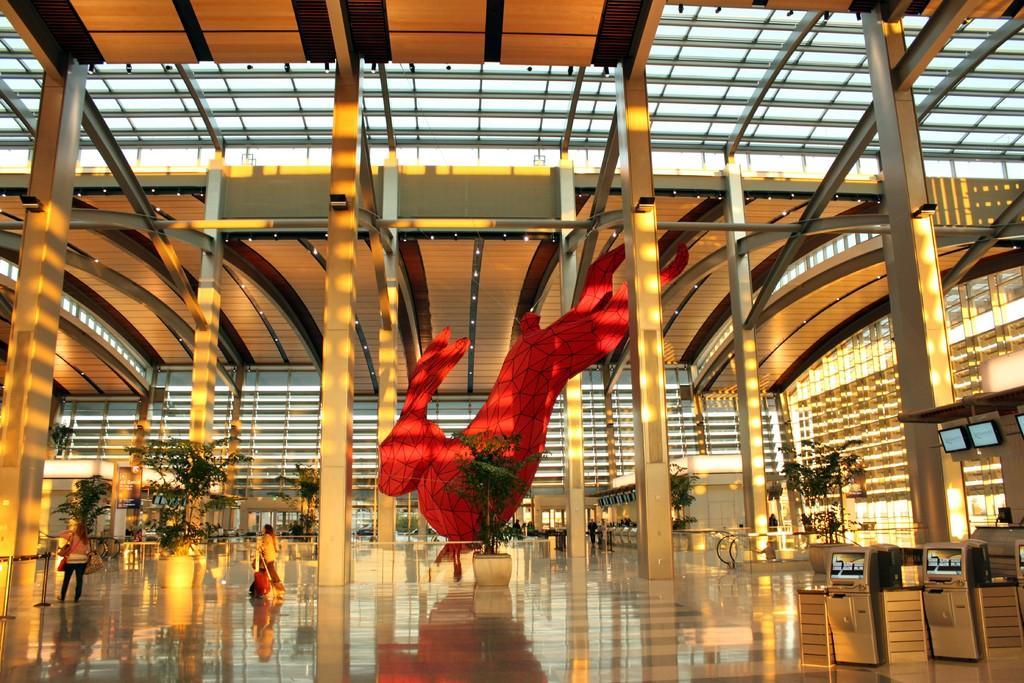Can you describe this image briefly? In this image I can see few people are inside the building. I can see the plants and the statue of an animal. To the right I can see the machines and the screens. I can see many lights and the pillars inside the building. 